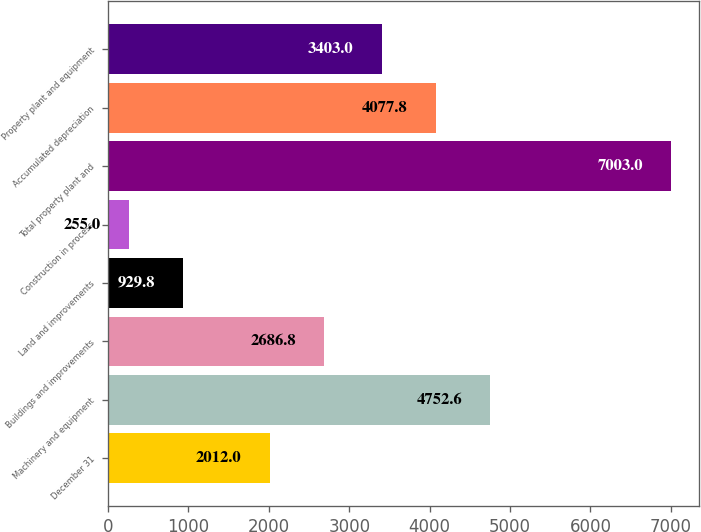Convert chart. <chart><loc_0><loc_0><loc_500><loc_500><bar_chart><fcel>December 31<fcel>Machinery and equipment<fcel>Buildings and improvements<fcel>Land and improvements<fcel>Construction in process<fcel>Total property plant and<fcel>Accumulated depreciation<fcel>Property plant and equipment<nl><fcel>2012<fcel>4752.6<fcel>2686.8<fcel>929.8<fcel>255<fcel>7003<fcel>4077.8<fcel>3403<nl></chart> 